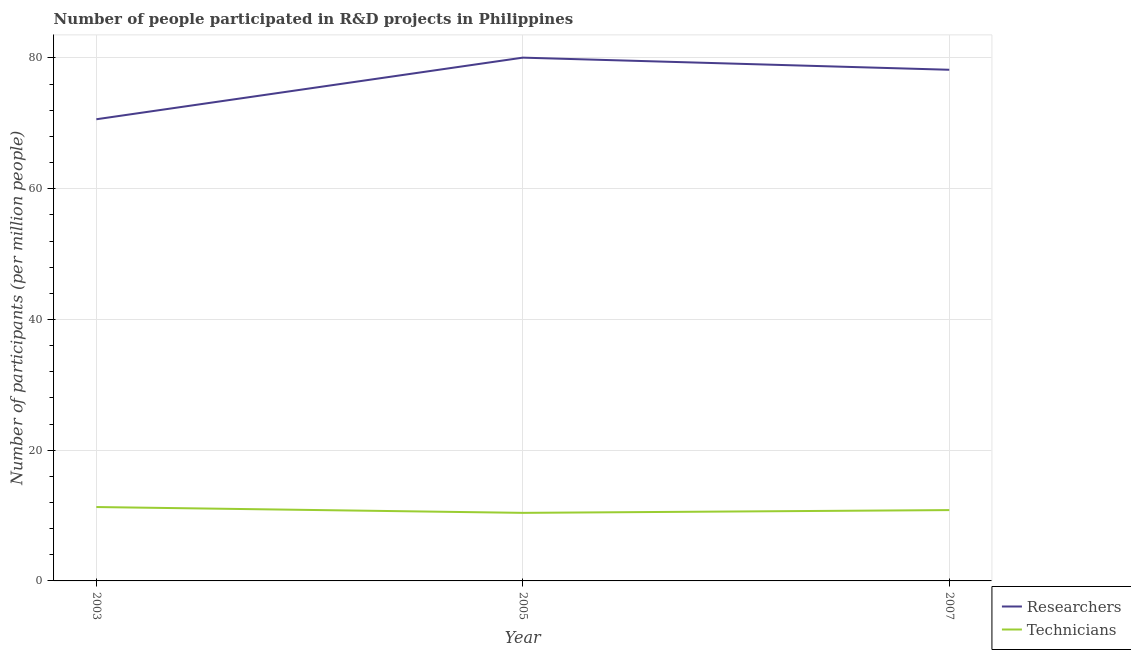How many different coloured lines are there?
Provide a short and direct response. 2. Does the line corresponding to number of technicians intersect with the line corresponding to number of researchers?
Your answer should be compact. No. What is the number of researchers in 2005?
Keep it short and to the point. 80.05. Across all years, what is the maximum number of technicians?
Offer a very short reply. 11.31. Across all years, what is the minimum number of researchers?
Make the answer very short. 70.63. In which year was the number of technicians maximum?
Ensure brevity in your answer.  2003. In which year was the number of researchers minimum?
Give a very brief answer. 2003. What is the total number of technicians in the graph?
Your answer should be very brief. 32.55. What is the difference between the number of technicians in 2003 and that in 2005?
Provide a short and direct response. 0.89. What is the difference between the number of researchers in 2003 and the number of technicians in 2005?
Ensure brevity in your answer.  60.21. What is the average number of researchers per year?
Provide a short and direct response. 76.29. In the year 2003, what is the difference between the number of researchers and number of technicians?
Your response must be concise. 59.32. What is the ratio of the number of researchers in 2003 to that in 2007?
Offer a very short reply. 0.9. Is the difference between the number of researchers in 2003 and 2007 greater than the difference between the number of technicians in 2003 and 2007?
Offer a very short reply. No. What is the difference between the highest and the second highest number of technicians?
Keep it short and to the point. 0.47. What is the difference between the highest and the lowest number of researchers?
Ensure brevity in your answer.  9.43. In how many years, is the number of technicians greater than the average number of technicians taken over all years?
Your answer should be compact. 1. Does the number of technicians monotonically increase over the years?
Provide a succinct answer. No. Is the number of researchers strictly greater than the number of technicians over the years?
Provide a short and direct response. Yes. How many lines are there?
Your answer should be very brief. 2. How many years are there in the graph?
Your response must be concise. 3. What is the difference between two consecutive major ticks on the Y-axis?
Give a very brief answer. 20. Are the values on the major ticks of Y-axis written in scientific E-notation?
Keep it short and to the point. No. Does the graph contain any zero values?
Your answer should be compact. No. How many legend labels are there?
Your response must be concise. 2. How are the legend labels stacked?
Your response must be concise. Vertical. What is the title of the graph?
Offer a very short reply. Number of people participated in R&D projects in Philippines. Does "Fertility rate" appear as one of the legend labels in the graph?
Offer a terse response. No. What is the label or title of the X-axis?
Your answer should be compact. Year. What is the label or title of the Y-axis?
Keep it short and to the point. Number of participants (per million people). What is the Number of participants (per million people) of Researchers in 2003?
Make the answer very short. 70.63. What is the Number of participants (per million people) in Technicians in 2003?
Provide a short and direct response. 11.31. What is the Number of participants (per million people) in Researchers in 2005?
Keep it short and to the point. 80.05. What is the Number of participants (per million people) of Technicians in 2005?
Provide a short and direct response. 10.41. What is the Number of participants (per million people) of Researchers in 2007?
Keep it short and to the point. 78.2. What is the Number of participants (per million people) of Technicians in 2007?
Make the answer very short. 10.84. Across all years, what is the maximum Number of participants (per million people) of Researchers?
Make the answer very short. 80.05. Across all years, what is the maximum Number of participants (per million people) in Technicians?
Provide a succinct answer. 11.31. Across all years, what is the minimum Number of participants (per million people) of Researchers?
Provide a succinct answer. 70.63. Across all years, what is the minimum Number of participants (per million people) in Technicians?
Make the answer very short. 10.41. What is the total Number of participants (per million people) in Researchers in the graph?
Your response must be concise. 228.88. What is the total Number of participants (per million people) of Technicians in the graph?
Ensure brevity in your answer.  32.55. What is the difference between the Number of participants (per million people) in Researchers in 2003 and that in 2005?
Keep it short and to the point. -9.43. What is the difference between the Number of participants (per million people) in Technicians in 2003 and that in 2005?
Make the answer very short. 0.89. What is the difference between the Number of participants (per million people) of Researchers in 2003 and that in 2007?
Your answer should be compact. -7.57. What is the difference between the Number of participants (per million people) of Technicians in 2003 and that in 2007?
Your answer should be very brief. 0.47. What is the difference between the Number of participants (per million people) in Researchers in 2005 and that in 2007?
Your response must be concise. 1.86. What is the difference between the Number of participants (per million people) in Technicians in 2005 and that in 2007?
Keep it short and to the point. -0.42. What is the difference between the Number of participants (per million people) in Researchers in 2003 and the Number of participants (per million people) in Technicians in 2005?
Make the answer very short. 60.21. What is the difference between the Number of participants (per million people) of Researchers in 2003 and the Number of participants (per million people) of Technicians in 2007?
Ensure brevity in your answer.  59.79. What is the difference between the Number of participants (per million people) in Researchers in 2005 and the Number of participants (per million people) in Technicians in 2007?
Ensure brevity in your answer.  69.22. What is the average Number of participants (per million people) of Researchers per year?
Offer a very short reply. 76.29. What is the average Number of participants (per million people) in Technicians per year?
Give a very brief answer. 10.85. In the year 2003, what is the difference between the Number of participants (per million people) in Researchers and Number of participants (per million people) in Technicians?
Your answer should be compact. 59.32. In the year 2005, what is the difference between the Number of participants (per million people) of Researchers and Number of participants (per million people) of Technicians?
Your answer should be very brief. 69.64. In the year 2007, what is the difference between the Number of participants (per million people) of Researchers and Number of participants (per million people) of Technicians?
Ensure brevity in your answer.  67.36. What is the ratio of the Number of participants (per million people) of Researchers in 2003 to that in 2005?
Your answer should be very brief. 0.88. What is the ratio of the Number of participants (per million people) of Technicians in 2003 to that in 2005?
Keep it short and to the point. 1.09. What is the ratio of the Number of participants (per million people) in Researchers in 2003 to that in 2007?
Give a very brief answer. 0.9. What is the ratio of the Number of participants (per million people) in Technicians in 2003 to that in 2007?
Provide a succinct answer. 1.04. What is the ratio of the Number of participants (per million people) of Researchers in 2005 to that in 2007?
Give a very brief answer. 1.02. What is the difference between the highest and the second highest Number of participants (per million people) of Researchers?
Offer a terse response. 1.86. What is the difference between the highest and the second highest Number of participants (per million people) of Technicians?
Offer a very short reply. 0.47. What is the difference between the highest and the lowest Number of participants (per million people) in Researchers?
Offer a very short reply. 9.43. What is the difference between the highest and the lowest Number of participants (per million people) of Technicians?
Your response must be concise. 0.89. 